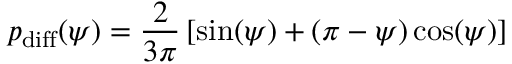<formula> <loc_0><loc_0><loc_500><loc_500>p _ { d i f f } ( \psi ) = \frac { 2 } { 3 \pi } \left [ \sin ( \psi ) + ( \pi - \psi ) \cos ( \psi ) \right ]</formula> 